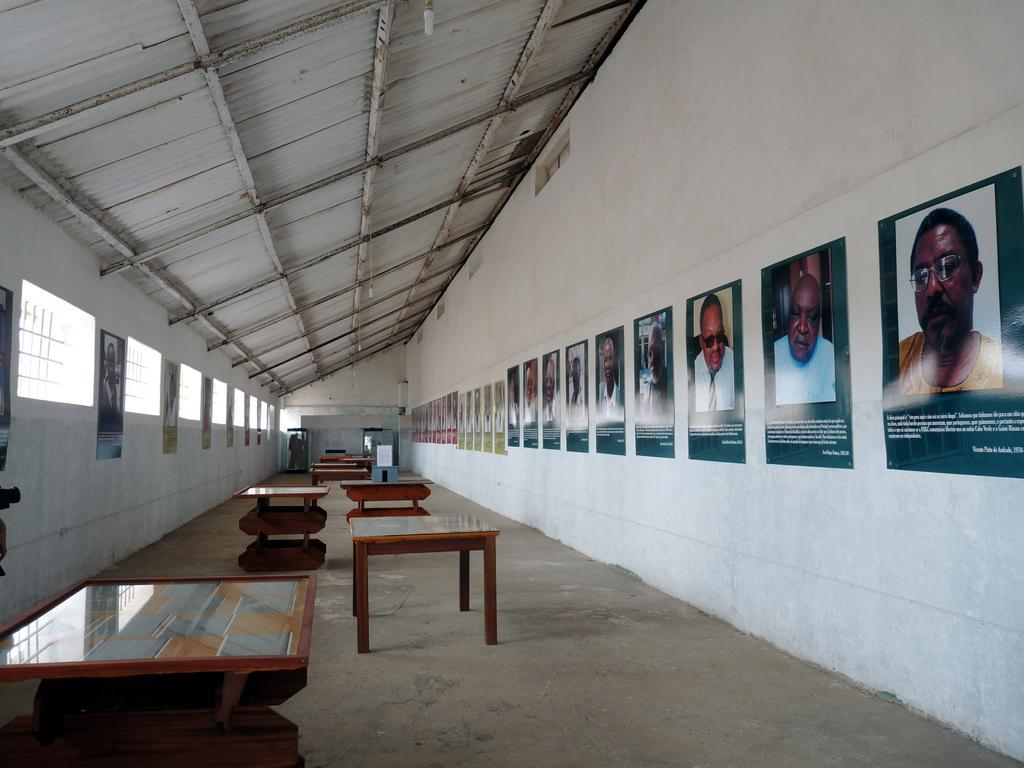What type of space is shown in the image? The image depicts a room. What furniture can be seen in the room? There are tables in the room. What decorative elements are present on the wall in the room? There are pictures attached to the wall in the room. What is visible in the background of the image? The background of the image includes a wall. Can you see the carpenter's quiver in the image? There is no carpenter or quiver present in the image. What color is the eye of the person in the image? There are no people or eyes visible in the image. 